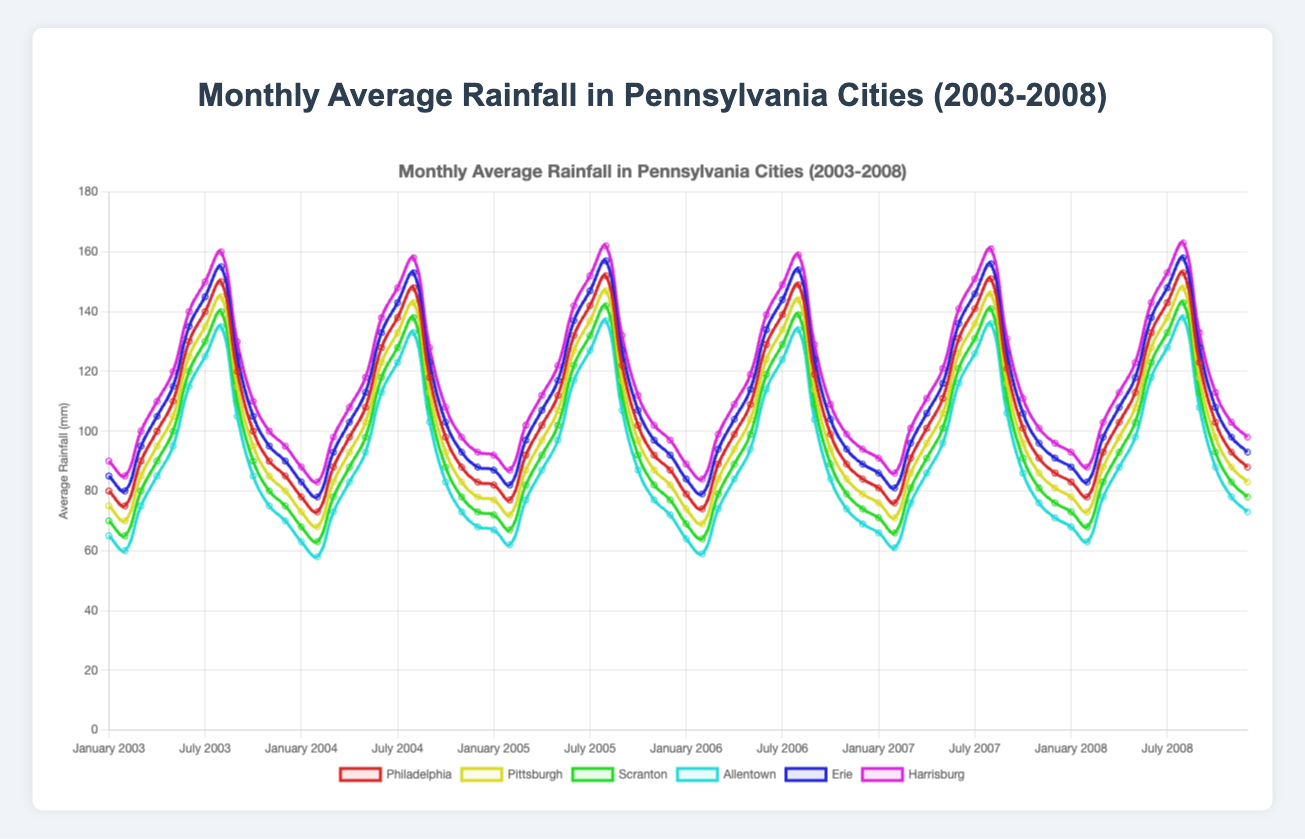What was the rainfall trend for Philadelphia from January to December in 2003? The rainfall trend for Philadelphia in 2003 starts at 80 mm in January, slightly decreases to a range around 70-75 mm until February, then increases steadily reaching peaks of 150 mm in August, and then decreases back to around 85 mm by December.
Answer: Increasing trend till August, then decreasing trend Which city had the highest average rainfall in July 2005, and what was the value? By inspecting the rainfall data for July 2005, Harrisburg had the highest average rainfall with 152 mm.
Answer: Harrisburg, 152 mm Compare the average rainfall between Erie and Pittsburgh in June 2004. In June 2004, the average rainfall for Erie was 133 mm and for Pittsburgh, it was 123 mm. Comparing these values, Erie had a higher average rainfall by 10 mm.
Answer: Erie had 10 mm more rainfall Is there any month in 2006 where Scranton had rainfall between 75 mm and 85 mm? In 2006, checking the values month by month, Scranton had rainfall between 75 mm and 85 mm in January (69 mm), February (64 mm), March (79 mm), April (89 mm). Thus, March was the month with 79 mm.
Answer: March How does July 2007 rainfall in Allentown compare with July 2008? In July 2007, rainfall in Allentown was 126 mm, and in July 2008, it was 128 mm. Comparing these, July 2008 had slightly more rainfall by 2 mm.
Answer: July 2008 had 2 mm more Which city shows the most significant increase in rainfall from January to August 2003? By inspecting each city's rainfall in January and August 2003: Philadelphia (80 mm to 150 mm, increase 70 mm), Pittsburgh (75 mm to 145 mm, increase 70 mm), Scranton (70 mm to 140 mm, increase 70 mm), Allentown (65 mm to 135 mm, increase 70 mm), Erie (85 mm to 155 mm, increase 70 mm), Harrisburg (90 mm to 160 mm, increase 70 mm). All cities show a 70 mm increase.
Answer: All cities, 70 mm What is the cumulative rainfall for Pittsburgh from April to June 2004? Adding the rainfall amounts for Pittsburgh from April to June 2004: April (93 mm) + May (103 mm) + June (123 mm) = 319 mm.
Answer: 319 mm Which city had a higher average annual rainfall in 2003, Philadelphia or Harrisburg? Summing up the monthly average rainfall for Philadelphia (sum of [80, 75, 90, 100, 110, 130, 140, 150, 120, 100, 90, 85]) gives 1270 mm, and for Harrisburg (sum of [90, 85, 100, 110, 120, 140, 150, 160, 130, 110, 100, 95]) gives 1390 mm. Dividing these sums by 12 gives monthly averages of around 105.83 mm for Philadelphia and 115.83 mm for Harrisburg.
Answer: Harrisburg How does the average rainfall in December 2004 compare among the cities? Looking at the average rainfall data for December 2004, the values are Philadelphia (83 mm), Pittsburgh (78 mm), Scranton (73 mm), Allentown (68 mm), Erie (88 mm), Harrisburg (93 mm). It shows Harrisburg has the highest rainfall, and Allentown has the lowest rainfall.
Answer: Highest in Harrisburg, lowest in Allentown 